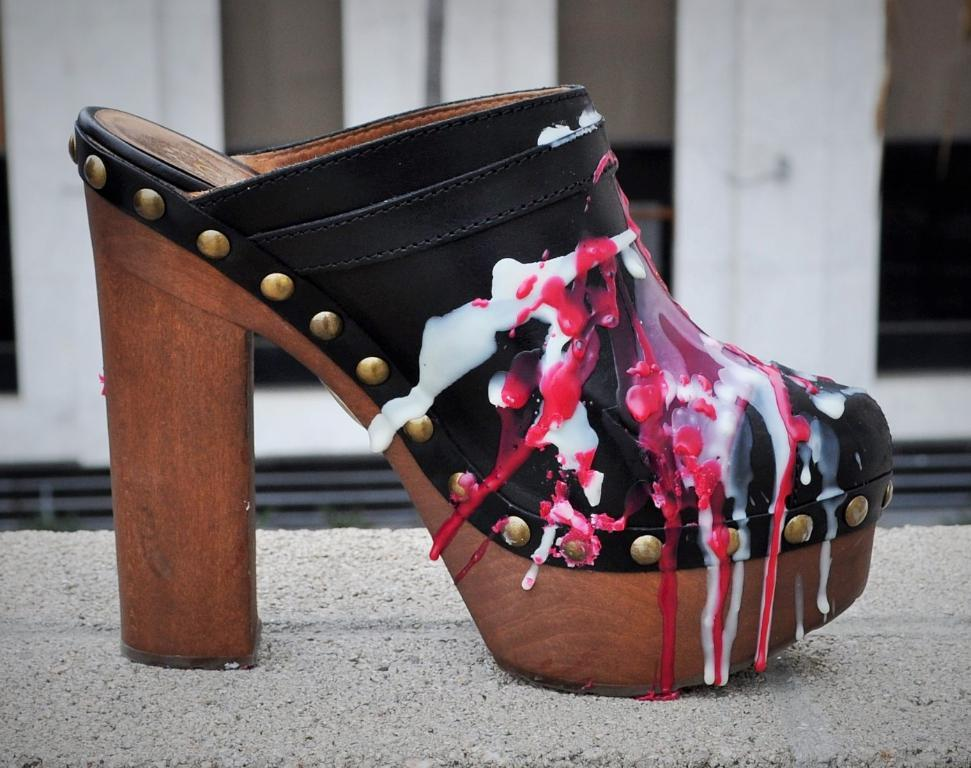What is placed on the floor in the image? There is a slipper placed on the floor. Is there anything else on the floor in the image? The image only shows a slipper placed on the floor. How many fingers can be seen holding the slipper in the image? There are no fingers visible in the image, as it only shows a slipper placed on the floor. 